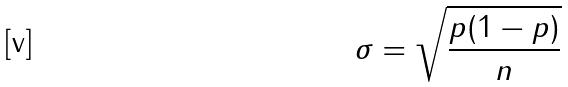<formula> <loc_0><loc_0><loc_500><loc_500>\sigma = \sqrt { \frac { p ( 1 - p ) } { n } }</formula> 